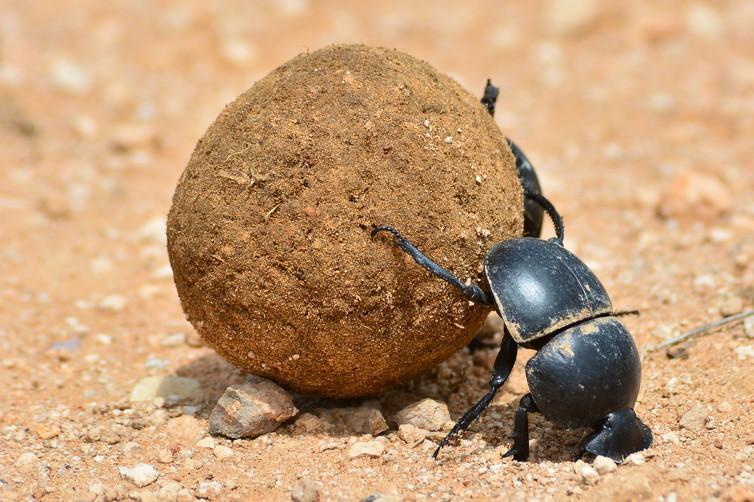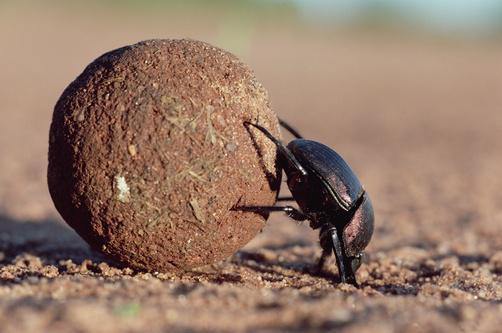The first image is the image on the left, the second image is the image on the right. For the images shown, is this caption "There is a beetle that that's at the very top of a dungball." true? Answer yes or no. No. The first image is the image on the left, the second image is the image on the right. For the images shown, is this caption "An image shows a beetle standing directly on top of a dung ball, with its body horizontal." true? Answer yes or no. No. 